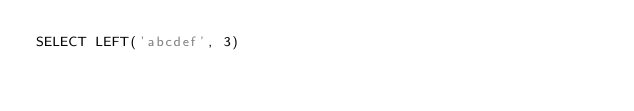Convert code to text. <code><loc_0><loc_0><loc_500><loc_500><_SQL_>SELECT LEFT('abcdef', 3)</code> 